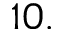Convert formula to latex. <formula><loc_0><loc_0><loc_500><loc_500>1 0 .</formula> 